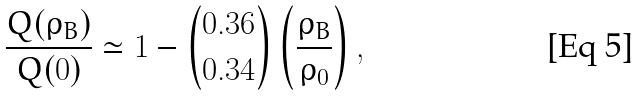<formula> <loc_0><loc_0><loc_500><loc_500>\frac { Q ( \rho _ { B } ) } { Q ( 0 ) } \simeq 1 - { 0 . 3 6 \choose 0 . 3 4 } \left ( \frac { \rho _ { B } } { \rho _ { 0 } } \right ) ,</formula> 